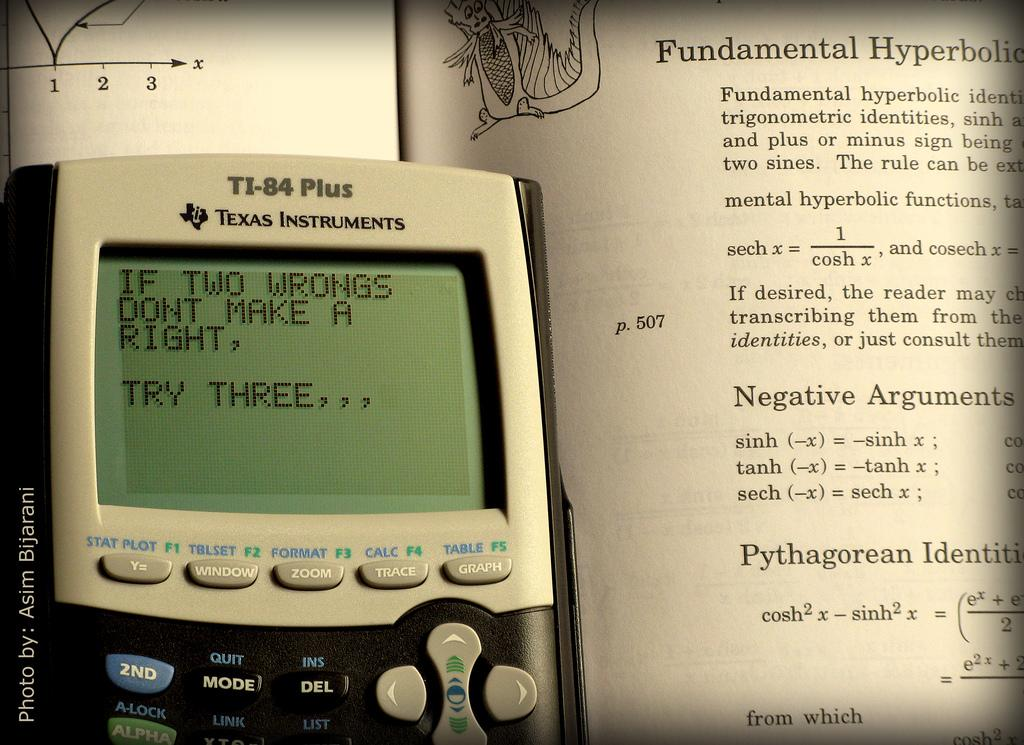<image>
Create a compact narrative representing the image presented. a smart phone with "Two wrongs don't make a right" displayed on it 